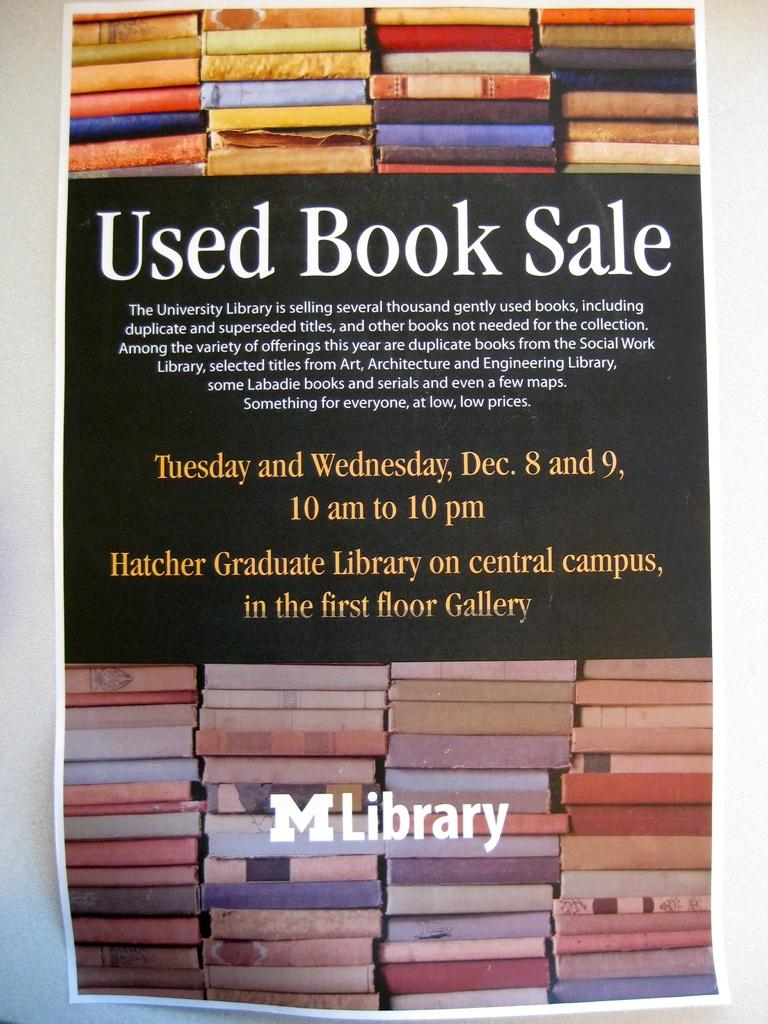Provide a one-sentence caption for the provided image. A flyer advertising a used book sale in December at a campus library. 